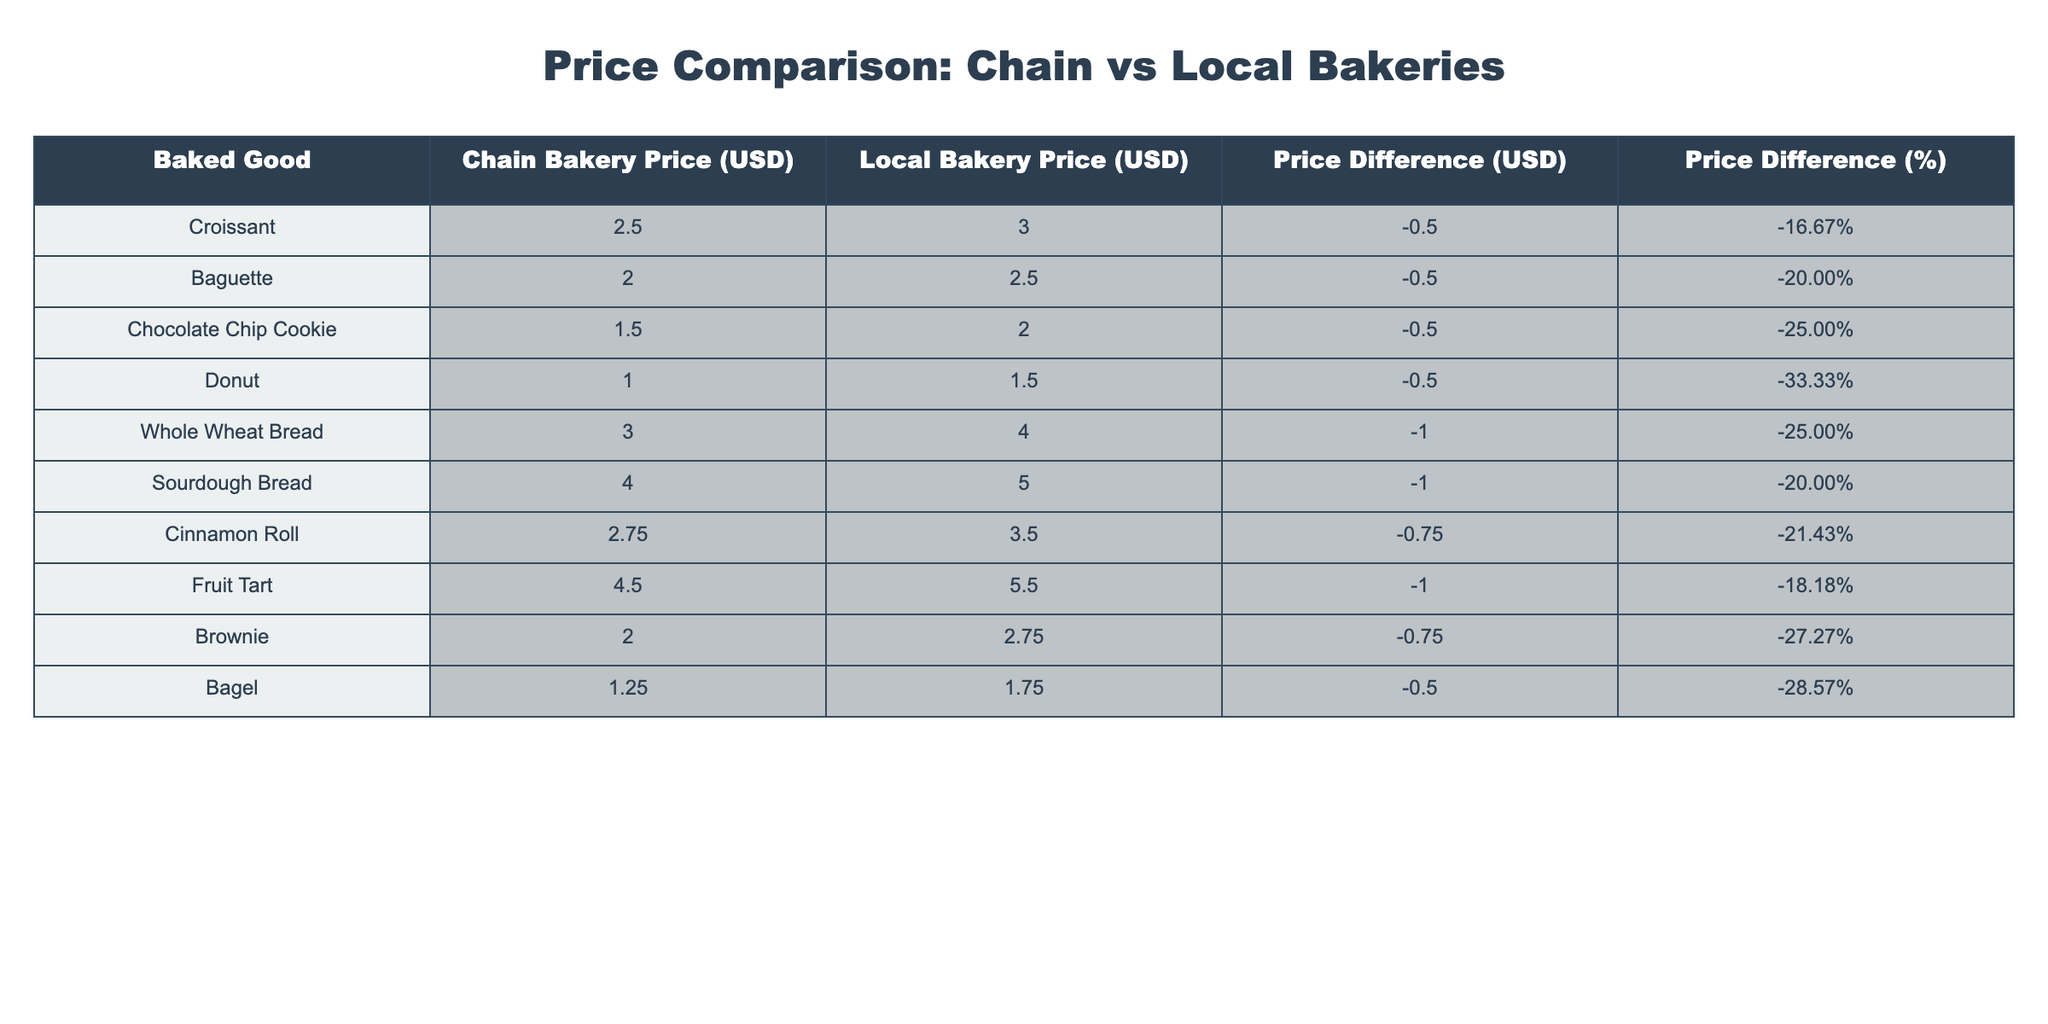What is the price of a Croissant at the chain bakery? The table lists the price of a Croissant at the chain bakery in the corresponding column, which is $2.50.
Answer: $2.50 What is the price difference between a Baguette at the local bakery and the chain bakery? The table shows that the Baguette is priced at $2.50 in the local bakery and $2.00 in the chain bakery, leading to a price difference of -$0.50.
Answer: -$0.50 Is the price of a Donut at the chain bakery lower than at the local bakery? The table presents the price of a Donut at the chain bakery as $1.00 and at the local bakery as $1.50. Since $1.00 is less than $1.50, the statement is true.
Answer: Yes Which baked good has the highest percentage price difference? Looking at the percentage price differences listed in the table, the Chocolate Chip Cookie has a difference of -25.00%, which is not the highest; instead, the Donut has the highest at -33.33%.
Answer: Donut What is the average price difference for the baked goods listed in the table? To find the average price difference, sum all the price differences: -0.50, -0.50, -0.50, -0.50, -1.00, -1.00, -0.75, -1.00, -0.75, -0.50. The sum is -7.00 and there are 10 goods. Therefore, the average is -7.00 / 10 = -0.70.
Answer: -0.70 What percentage price difference does the Brownie have compared to the chain bakery? The price of a Brownie in the chain bakery is $2.00 and at the local bakery it is $2.75. The price difference is -$0.75 which represents a -27.27% price difference, based on the given column.
Answer: -27.27% How many baked goods are sold at a lower price in chain bakeries compared to local bakeries? By examining the chain and local bakery prices in the table, all ten baked goods are cheaper at chain bakeries than local ones.
Answer: 10 If we consider the prices for Sourdough Bread in both bakeries, what is the difference in USD and percentage? The Sourdough Bread is priced at $4.00 at the chain bakery and $5.00 at the local bakery. The difference in USD is -$1.00 and the percentage difference is -20.00%.
Answer: -1.00 USD, -20.00% Which baked good has the lowest price at the chain bakery? The table indicates that the Donut is priced at $1.00, which is the lowest price listed for any baked good at the chain bakery.
Answer: Donut 